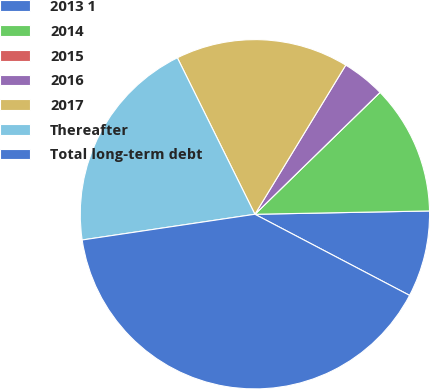Convert chart to OTSL. <chart><loc_0><loc_0><loc_500><loc_500><pie_chart><fcel>2013 1<fcel>2014<fcel>2015<fcel>2016<fcel>2017<fcel>Thereafter<fcel>Total long-term debt<nl><fcel>7.99%<fcel>11.99%<fcel>0.0%<fcel>4.0%<fcel>16.03%<fcel>20.03%<fcel>39.96%<nl></chart> 